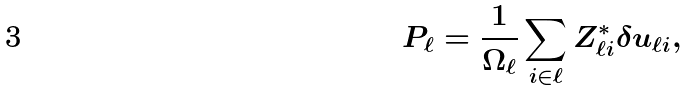Convert formula to latex. <formula><loc_0><loc_0><loc_500><loc_500>P _ { \ell } = \frac { 1 } { \Omega _ { \ell } } \sum _ { i \in \ell } Z ^ { * } _ { \ell i } \delta u _ { \ell i } ,</formula> 